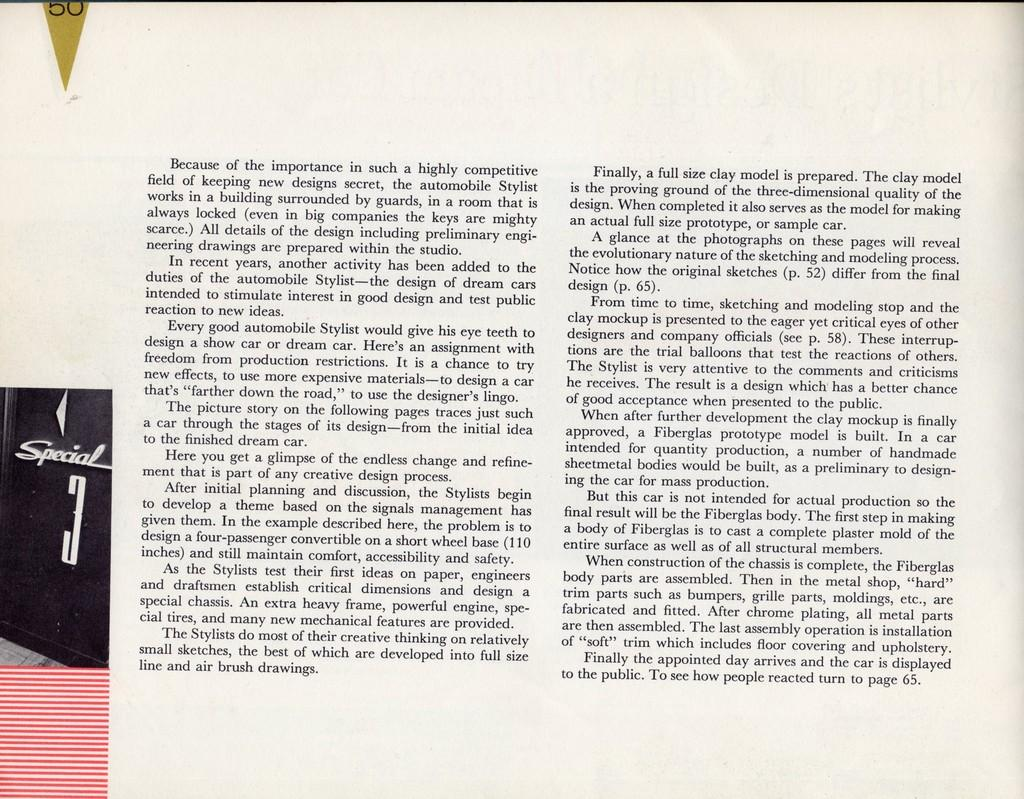<image>
Write a terse but informative summary of the picture. A news article about the Special and its automotive design is shown. 